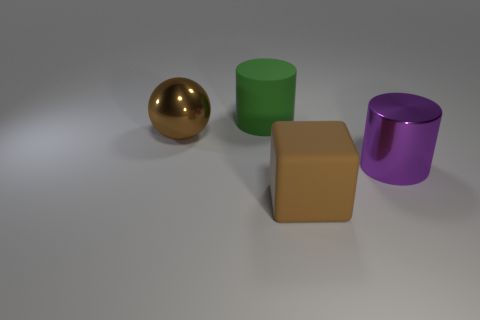Is the purple metal cylinder the same size as the green object?
Offer a very short reply. Yes. What is the color of the large cylinder that is on the left side of the big metal object that is right of the big green matte thing?
Give a very brief answer. Green. The block is what color?
Your response must be concise. Brown. Are there any large metal balls that have the same color as the big rubber cylinder?
Offer a terse response. No. There is a large matte object behind the big brown shiny object; is it the same color as the big cube?
Your answer should be compact. No. How many things are large cylinders that are in front of the big green cylinder or brown rubber cylinders?
Your answer should be very brief. 1. There is a green matte cylinder; are there any large purple metal things behind it?
Provide a short and direct response. No. What material is the large object that is the same color as the shiny sphere?
Keep it short and to the point. Rubber. Is the large ball in front of the green object made of the same material as the big green thing?
Your answer should be very brief. No. Is there a shiny cylinder that is left of the shiny object that is in front of the big brown object left of the large brown cube?
Ensure brevity in your answer.  No. 